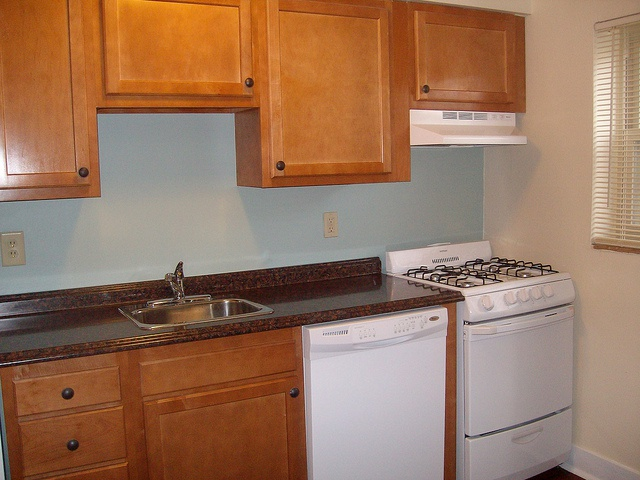Describe the objects in this image and their specific colors. I can see oven in maroon, darkgray, and gray tones and sink in maroon, black, and gray tones in this image. 